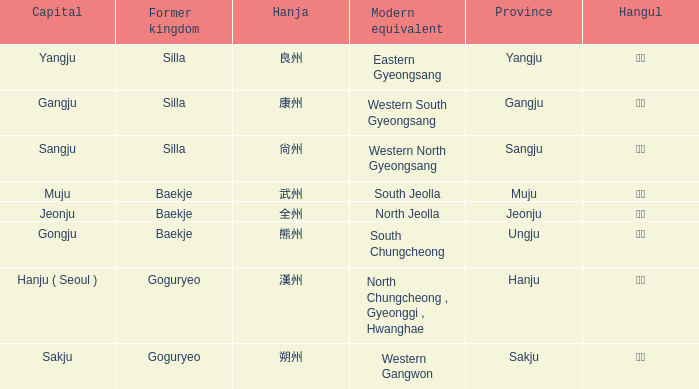The hanja 朔州 is for what province? Sakju. 